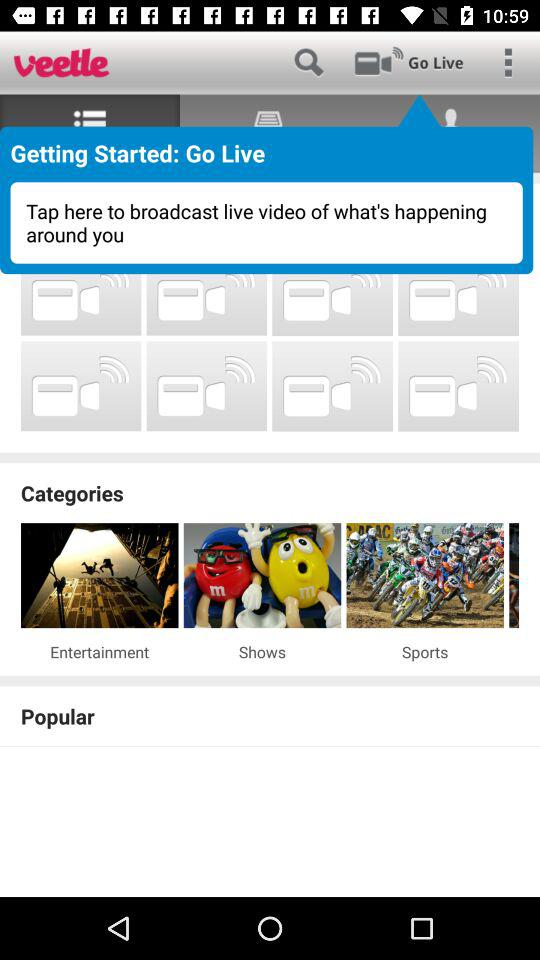What is the name of the application? The name of the application is "veetle". 